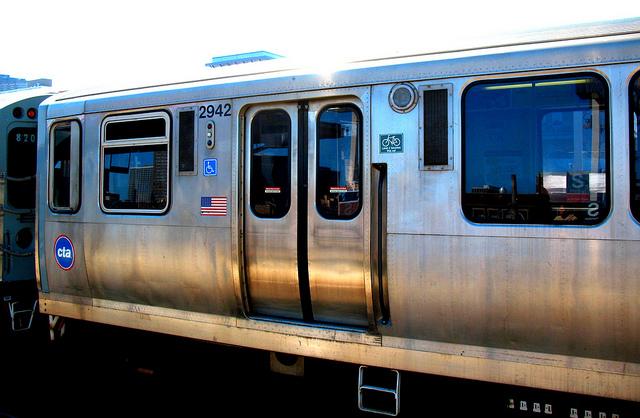What is the second number is the sequence on the train car?
Give a very brief answer. 9. Is this a passenger train?
Give a very brief answer. Yes. What color is the train?
Be succinct. Silver. Is this train in the United States?
Be succinct. Yes. 